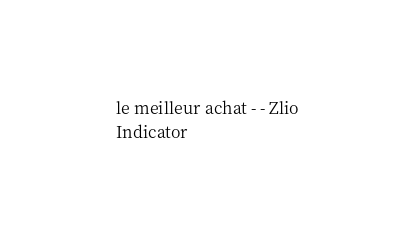<code> <loc_0><loc_0><loc_500><loc_500><_XML_>	 le meilleur achat - - Zlio 
	 Indicator 
</code> 